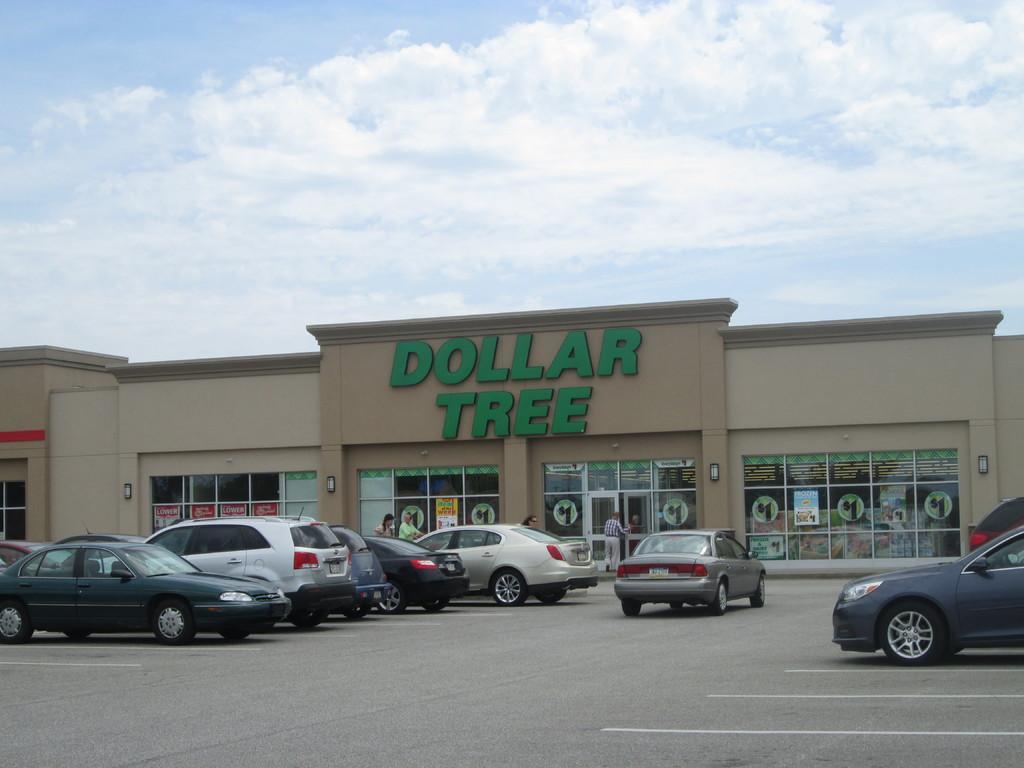Describe this image in one or two sentences. In this image there is a building in middle of this image and there are some cars at bottom of this image and there is a road below to this image , and there is a cloudy sky at top of this image. 